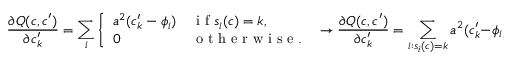Convert formula to latex. <formula><loc_0><loc_0><loc_500><loc_500>\frac { \partial Q ( c , c ^ { \prime } ) } { \partial c _ { k } ^ { \prime } } = \sum _ { i } \left \{ \begin{array} { l l } { a ^ { 2 } ( c _ { k } ^ { \prime } - \phi _ { i } ) } & { i f s _ { i } ( c ) = k , } \\ { 0 } & { o t h e r w i s e . } \end{array} \rightarrow \frac { \partial Q ( c , c ^ { \prime } ) } { \partial c _ { k } ^ { \prime } } = \sum _ { i \colon s _ { i } ( c ) = k } a ^ { 2 } ( c _ { k } ^ { \prime } - \phi _ { i } ) .</formula> 